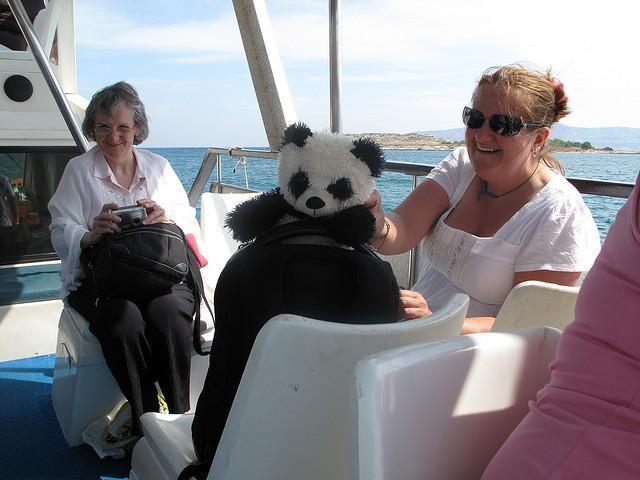How many people are in the picture?
Give a very brief answer. 3. How many handbags are there?
Give a very brief answer. 2. How many chairs are there?
Give a very brief answer. 4. 